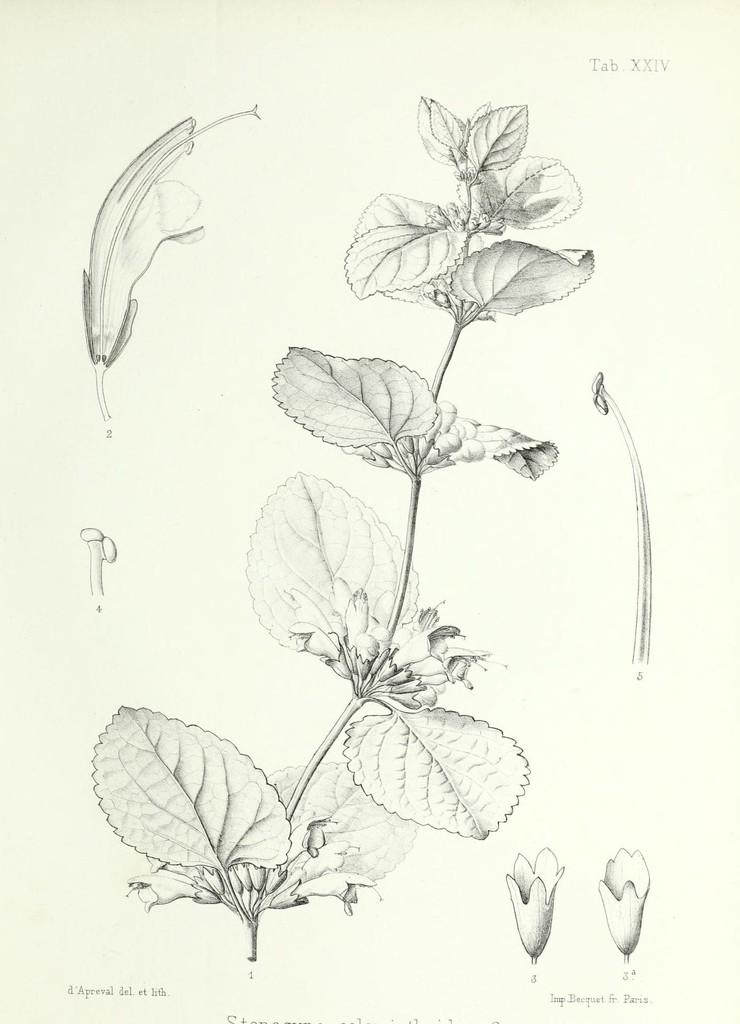What is the main subject of the image? The image appears to be a photograph of a paper. What is depicted on the paper? There are leaves and a plant in the image. Can you describe the plant in the image? The plant has a flower on the left side. What type of street is visible in the image? There is no street visible in the image; it is a photograph of a paper depicting a plant. What holiday is being celebrated in the image? There is no indication of a holiday being celebrated in the image. 